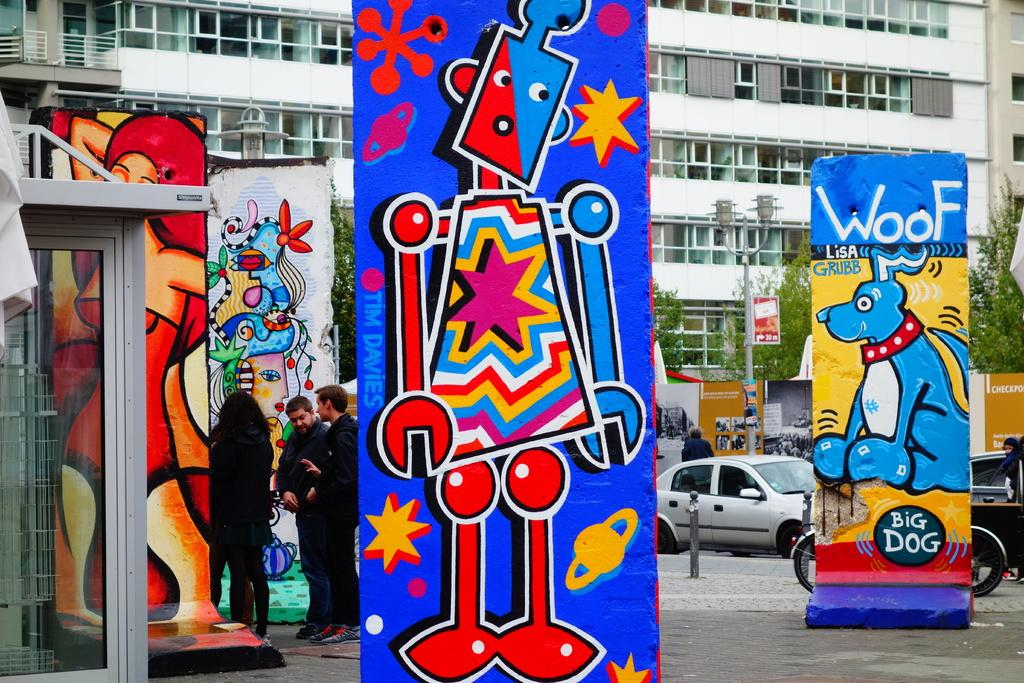<image>
Offer a succinct explanation of the picture presented. A group of people are standing in a parking lot with large art displays and one of them has a blue dog that says Woof. 